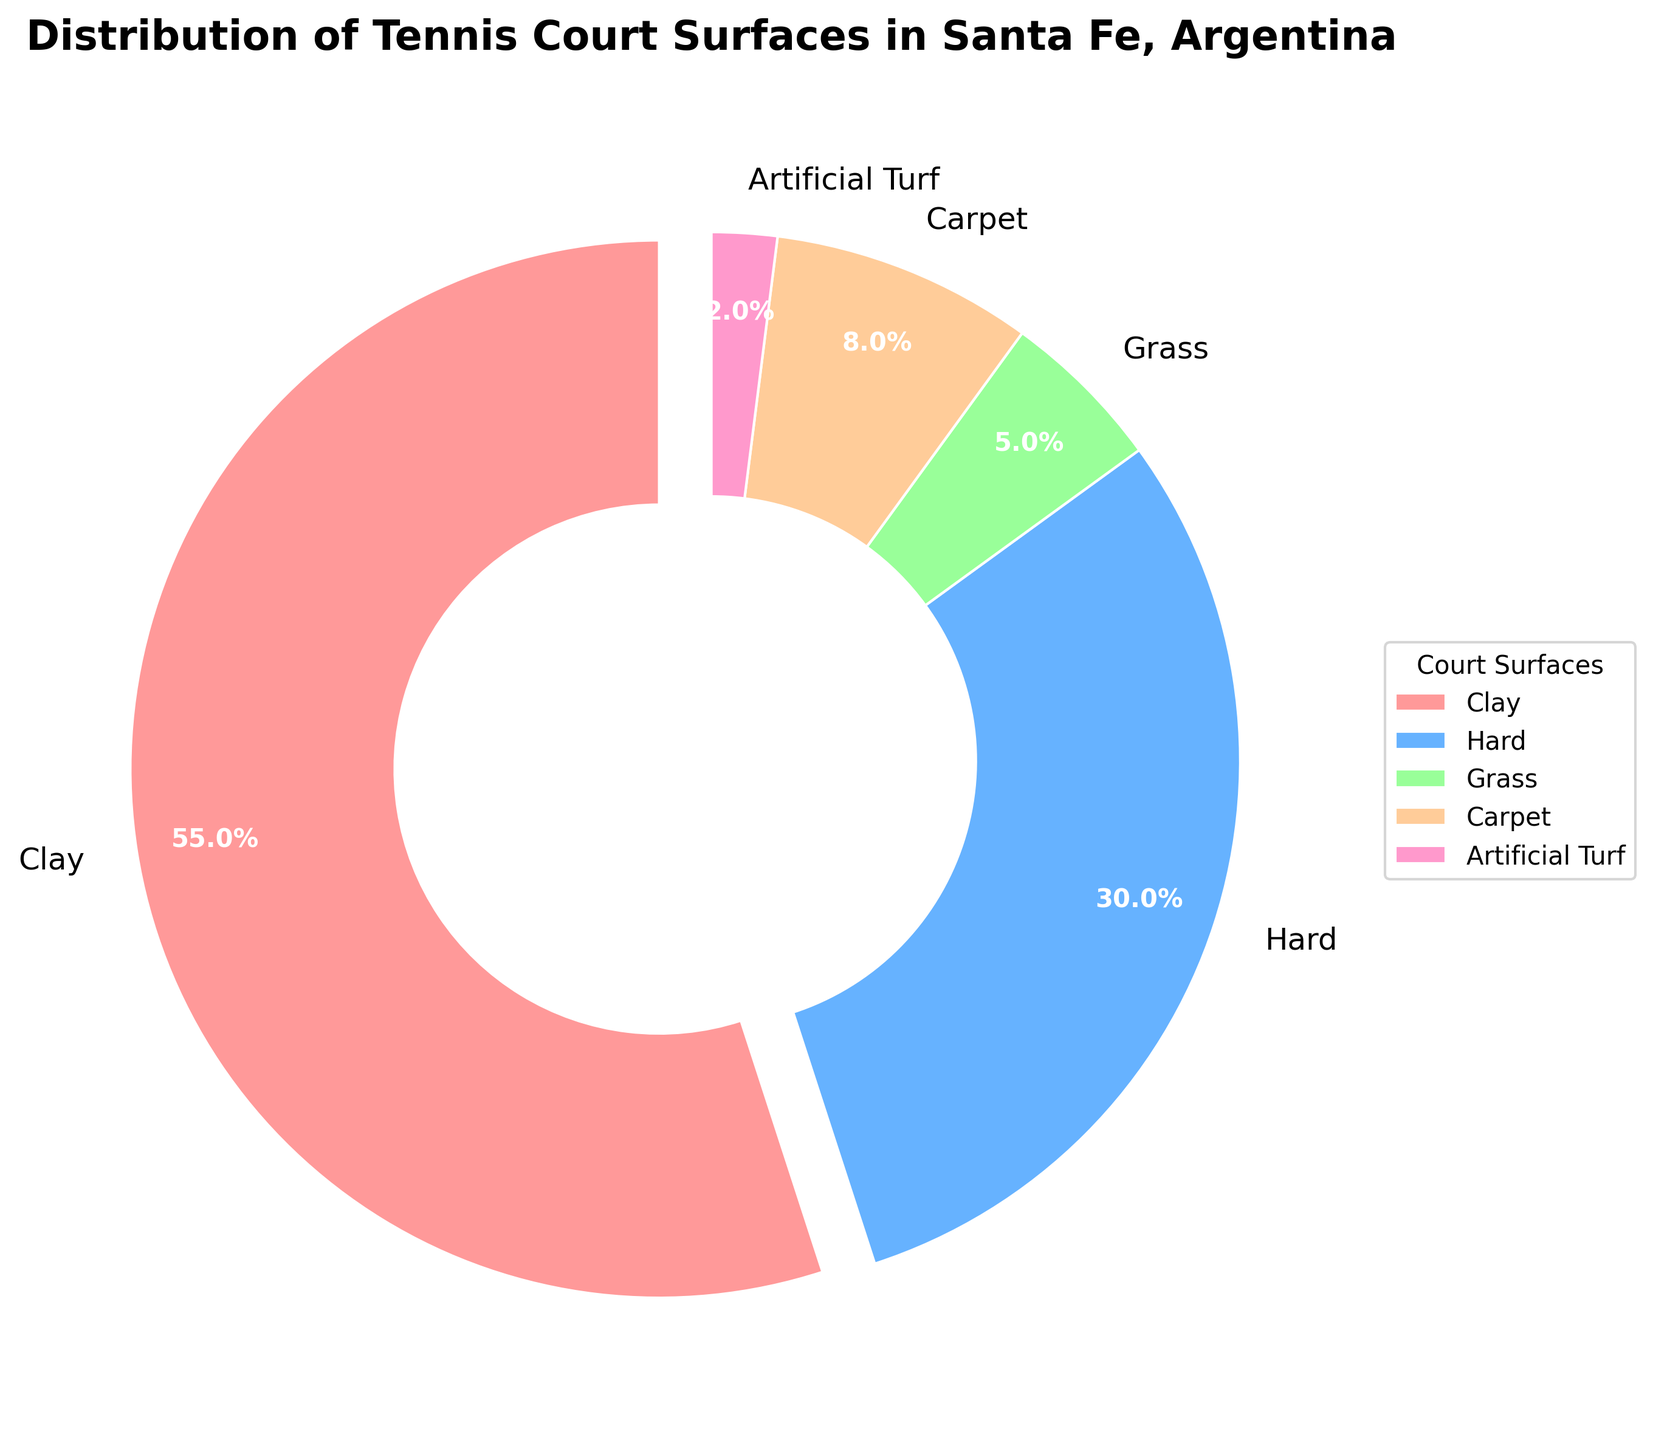What is the most common court surface in Santa Fe? Look at the pie chart and identify the category with the largest segment. The 'Clay' section is the largest.
Answer: Clay Which court surface is the least common in Santa Fe? Look at the pie chart and identify the category with the smallest segment. The 'Artificial Turf' section is the smallest.
Answer: Artificial Turf What percentage of tennis courts in Santa Fe are either Hard or Carpet surfaces? Refer to the percentages for Hard and Carpet surfaces in the pie chart, then sum them up (30% + 8% = 38%).
Answer: 38% How much larger is the percentage of Clay courts compared to Grass courts? Find the difference between the percentages of Clay (55%) and Grass (5%) surfaces by subtracting 5% from 55% (55% - 5% = 50%).
Answer: 50% Which court surface is more common: Carpet or Artificial Turf? Compare the percentages for Carpet (8%) and Artificial Turf (2%) surfaces. Carpet's percentage is larger.
Answer: Carpet What is the combined percentage of non-clay court surfaces? Sum the percentages of Hard, Grass, Carpet, and Artificial Turf surfaces: 30% + 5% + 8% + 2% = 45%.
Answer: 45% Are Clay courts more than twice as common as Hard courts? Check if the percentage of Clay courts (55%) is more than twice the percentage of Hard courts (30%). Twice 30% is 60%, and since 55% is less than 60%, they are not more than twice as common.
Answer: No Which color represents the Grass court surface in the pie chart? Identify the color corresponding to Grass by looking at the legend in the pie chart. Grass courts are represented by a green segment.
Answer: Green How does the percentage of Carpet courts compare to that of Artificial Turf courts? Compare the percentages of Carpet (8%) and Artificial Turf (2%) surfaces. Carpet's percentage is significantly larger than Artificial Turf's.
Answer: Carpet is significantly larger What is the difference in percentage between Grass and Artificial Turf courts? Subtract the percentage of Artificial Turf (2%) from the percentage of Grass (5%): 5% - 2% = 3%.
Answer: 3% 